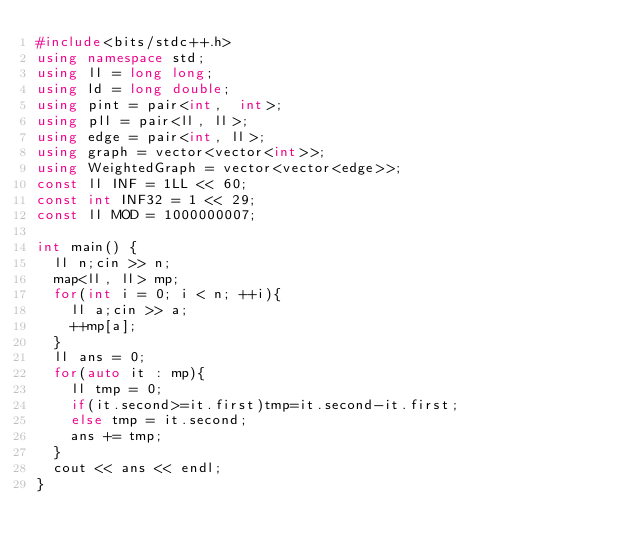<code> <loc_0><loc_0><loc_500><loc_500><_C++_>#include<bits/stdc++.h>
using namespace std;
using ll = long long;
using ld = long double;
using pint = pair<int,  int>;
using pll = pair<ll, ll>;
using edge = pair<int, ll>;
using graph = vector<vector<int>>; 
using WeightedGraph = vector<vector<edge>>;
const ll INF = 1LL << 60;
const int INF32 = 1 << 29;
const ll MOD = 1000000007;

int main() {
  ll n;cin >> n;
  map<ll, ll> mp;
  for(int i = 0; i < n; ++i){
    ll a;cin >> a;
    ++mp[a];
  }
  ll ans = 0;
  for(auto it : mp){
    ll tmp = 0;
    if(it.second>=it.first)tmp=it.second-it.first;
    else tmp = it.second;
    ans += tmp;
  }
  cout << ans << endl;
}

</code> 